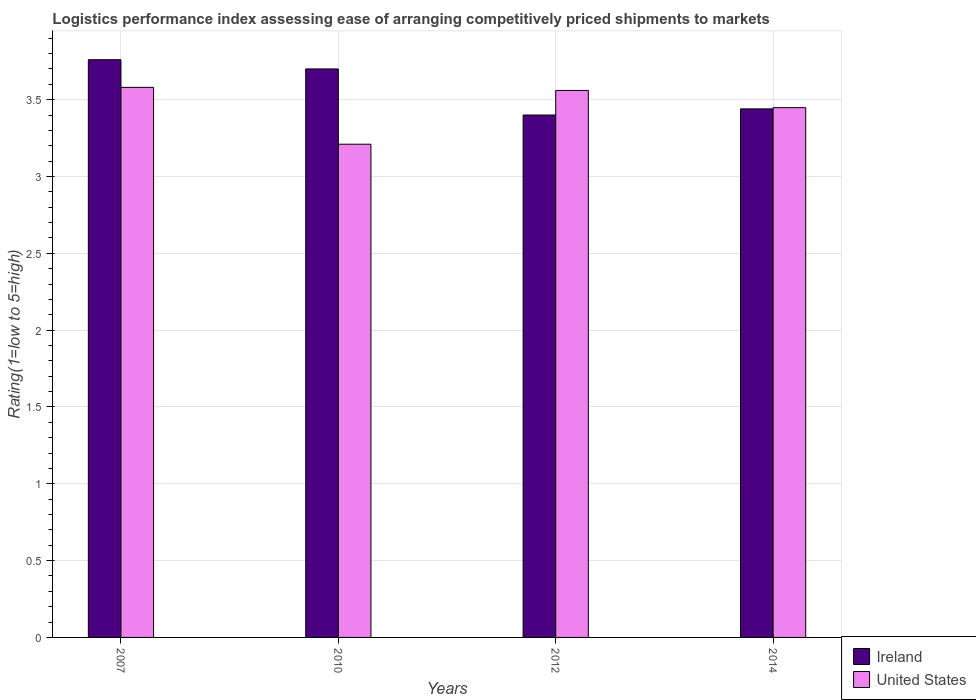How many different coloured bars are there?
Provide a succinct answer. 2. How many groups of bars are there?
Provide a short and direct response. 4. Are the number of bars on each tick of the X-axis equal?
Give a very brief answer. Yes. How many bars are there on the 2nd tick from the right?
Make the answer very short. 2. What is the label of the 1st group of bars from the left?
Your response must be concise. 2007. What is the Logistic performance index in Ireland in 2010?
Provide a short and direct response. 3.7. Across all years, what is the maximum Logistic performance index in Ireland?
Ensure brevity in your answer.  3.76. Across all years, what is the minimum Logistic performance index in United States?
Offer a very short reply. 3.21. In which year was the Logistic performance index in United States maximum?
Provide a short and direct response. 2007. In which year was the Logistic performance index in Ireland minimum?
Ensure brevity in your answer.  2012. What is the total Logistic performance index in Ireland in the graph?
Make the answer very short. 14.3. What is the difference between the Logistic performance index in Ireland in 2010 and that in 2014?
Provide a succinct answer. 0.26. What is the difference between the Logistic performance index in United States in 2007 and the Logistic performance index in Ireland in 2014?
Your answer should be very brief. 0.14. What is the average Logistic performance index in United States per year?
Provide a short and direct response. 3.45. In the year 2012, what is the difference between the Logistic performance index in Ireland and Logistic performance index in United States?
Your answer should be very brief. -0.16. In how many years, is the Logistic performance index in United States greater than 2.2?
Provide a succinct answer. 4. What is the ratio of the Logistic performance index in Ireland in 2007 to that in 2010?
Your response must be concise. 1.02. Is the difference between the Logistic performance index in Ireland in 2007 and 2010 greater than the difference between the Logistic performance index in United States in 2007 and 2010?
Offer a terse response. No. What is the difference between the highest and the second highest Logistic performance index in Ireland?
Give a very brief answer. 0.06. What is the difference between the highest and the lowest Logistic performance index in Ireland?
Give a very brief answer. 0.36. What does the 1st bar from the left in 2007 represents?
Your response must be concise. Ireland. What does the 1st bar from the right in 2014 represents?
Offer a very short reply. United States. How many bars are there?
Offer a terse response. 8. Does the graph contain any zero values?
Give a very brief answer. No. Does the graph contain grids?
Keep it short and to the point. Yes. What is the title of the graph?
Provide a succinct answer. Logistics performance index assessing ease of arranging competitively priced shipments to markets. What is the label or title of the Y-axis?
Keep it short and to the point. Rating(1=low to 5=high). What is the Rating(1=low to 5=high) in Ireland in 2007?
Your response must be concise. 3.76. What is the Rating(1=low to 5=high) in United States in 2007?
Your answer should be compact. 3.58. What is the Rating(1=low to 5=high) of Ireland in 2010?
Provide a succinct answer. 3.7. What is the Rating(1=low to 5=high) in United States in 2010?
Provide a succinct answer. 3.21. What is the Rating(1=low to 5=high) of United States in 2012?
Your response must be concise. 3.56. What is the Rating(1=low to 5=high) of Ireland in 2014?
Provide a succinct answer. 3.44. What is the Rating(1=low to 5=high) of United States in 2014?
Your response must be concise. 3.45. Across all years, what is the maximum Rating(1=low to 5=high) in Ireland?
Keep it short and to the point. 3.76. Across all years, what is the maximum Rating(1=low to 5=high) of United States?
Keep it short and to the point. 3.58. Across all years, what is the minimum Rating(1=low to 5=high) in Ireland?
Keep it short and to the point. 3.4. Across all years, what is the minimum Rating(1=low to 5=high) in United States?
Your response must be concise. 3.21. What is the total Rating(1=low to 5=high) in Ireland in the graph?
Make the answer very short. 14.3. What is the total Rating(1=low to 5=high) of United States in the graph?
Give a very brief answer. 13.8. What is the difference between the Rating(1=low to 5=high) in United States in 2007 and that in 2010?
Provide a short and direct response. 0.37. What is the difference between the Rating(1=low to 5=high) in Ireland in 2007 and that in 2012?
Offer a very short reply. 0.36. What is the difference between the Rating(1=low to 5=high) in Ireland in 2007 and that in 2014?
Make the answer very short. 0.32. What is the difference between the Rating(1=low to 5=high) in United States in 2007 and that in 2014?
Offer a terse response. 0.13. What is the difference between the Rating(1=low to 5=high) in United States in 2010 and that in 2012?
Your answer should be very brief. -0.35. What is the difference between the Rating(1=low to 5=high) in Ireland in 2010 and that in 2014?
Your answer should be compact. 0.26. What is the difference between the Rating(1=low to 5=high) of United States in 2010 and that in 2014?
Keep it short and to the point. -0.24. What is the difference between the Rating(1=low to 5=high) of Ireland in 2012 and that in 2014?
Your response must be concise. -0.04. What is the difference between the Rating(1=low to 5=high) of United States in 2012 and that in 2014?
Provide a short and direct response. 0.11. What is the difference between the Rating(1=low to 5=high) in Ireland in 2007 and the Rating(1=low to 5=high) in United States in 2010?
Provide a succinct answer. 0.55. What is the difference between the Rating(1=low to 5=high) of Ireland in 2007 and the Rating(1=low to 5=high) of United States in 2014?
Make the answer very short. 0.31. What is the difference between the Rating(1=low to 5=high) in Ireland in 2010 and the Rating(1=low to 5=high) in United States in 2012?
Offer a terse response. 0.14. What is the difference between the Rating(1=low to 5=high) of Ireland in 2010 and the Rating(1=low to 5=high) of United States in 2014?
Ensure brevity in your answer.  0.25. What is the difference between the Rating(1=low to 5=high) in Ireland in 2012 and the Rating(1=low to 5=high) in United States in 2014?
Give a very brief answer. -0.05. What is the average Rating(1=low to 5=high) of Ireland per year?
Offer a very short reply. 3.58. What is the average Rating(1=low to 5=high) in United States per year?
Your answer should be very brief. 3.45. In the year 2007, what is the difference between the Rating(1=low to 5=high) of Ireland and Rating(1=low to 5=high) of United States?
Offer a very short reply. 0.18. In the year 2010, what is the difference between the Rating(1=low to 5=high) in Ireland and Rating(1=low to 5=high) in United States?
Ensure brevity in your answer.  0.49. In the year 2012, what is the difference between the Rating(1=low to 5=high) in Ireland and Rating(1=low to 5=high) in United States?
Provide a short and direct response. -0.16. In the year 2014, what is the difference between the Rating(1=low to 5=high) in Ireland and Rating(1=low to 5=high) in United States?
Provide a succinct answer. -0.01. What is the ratio of the Rating(1=low to 5=high) in Ireland in 2007 to that in 2010?
Your answer should be very brief. 1.02. What is the ratio of the Rating(1=low to 5=high) of United States in 2007 to that in 2010?
Ensure brevity in your answer.  1.12. What is the ratio of the Rating(1=low to 5=high) in Ireland in 2007 to that in 2012?
Ensure brevity in your answer.  1.11. What is the ratio of the Rating(1=low to 5=high) of United States in 2007 to that in 2012?
Your response must be concise. 1.01. What is the ratio of the Rating(1=low to 5=high) of Ireland in 2007 to that in 2014?
Your response must be concise. 1.09. What is the ratio of the Rating(1=low to 5=high) of United States in 2007 to that in 2014?
Provide a succinct answer. 1.04. What is the ratio of the Rating(1=low to 5=high) of Ireland in 2010 to that in 2012?
Provide a succinct answer. 1.09. What is the ratio of the Rating(1=low to 5=high) in United States in 2010 to that in 2012?
Offer a terse response. 0.9. What is the ratio of the Rating(1=low to 5=high) in Ireland in 2010 to that in 2014?
Give a very brief answer. 1.08. What is the ratio of the Rating(1=low to 5=high) in Ireland in 2012 to that in 2014?
Your response must be concise. 0.99. What is the ratio of the Rating(1=low to 5=high) in United States in 2012 to that in 2014?
Your response must be concise. 1.03. What is the difference between the highest and the second highest Rating(1=low to 5=high) of Ireland?
Your answer should be very brief. 0.06. What is the difference between the highest and the second highest Rating(1=low to 5=high) of United States?
Offer a very short reply. 0.02. What is the difference between the highest and the lowest Rating(1=low to 5=high) in Ireland?
Your response must be concise. 0.36. What is the difference between the highest and the lowest Rating(1=low to 5=high) in United States?
Keep it short and to the point. 0.37. 